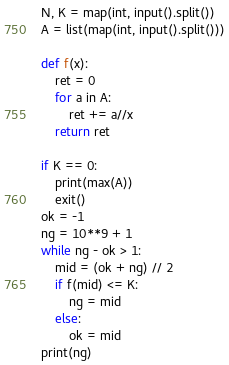<code> <loc_0><loc_0><loc_500><loc_500><_Python_>N, K = map(int, input().split())
A = list(map(int, input().split()))

def f(x):
    ret = 0
    for a in A:
        ret += a//x
    return ret

if K == 0:
    print(max(A))
    exit()
ok = -1
ng = 10**9 + 1
while ng - ok > 1:
    mid = (ok + ng) // 2
    if f(mid) <= K:
        ng = mid
    else:
        ok = mid
print(ng)</code> 